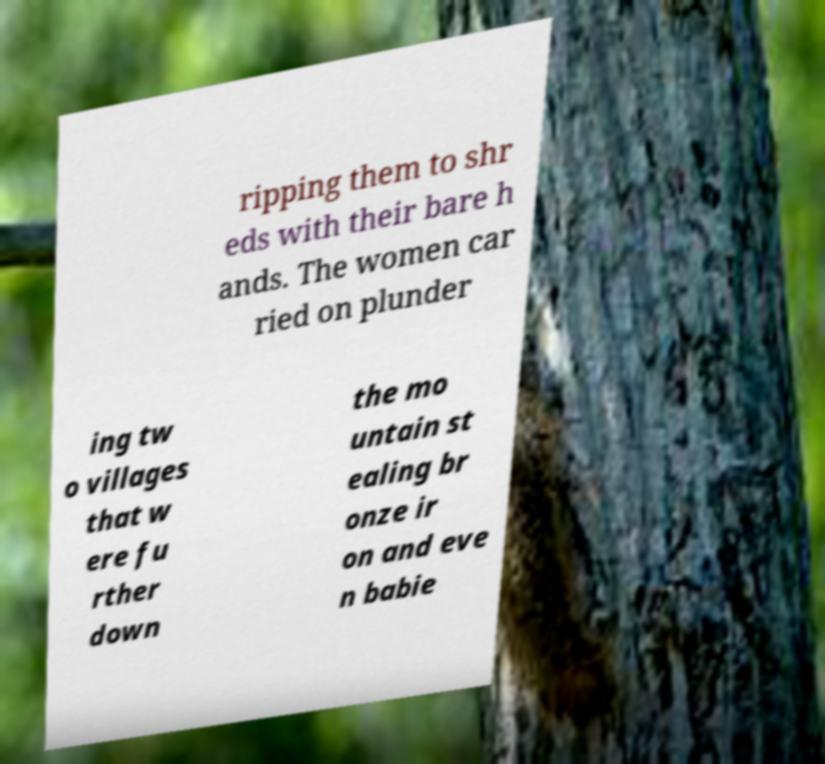Can you read and provide the text displayed in the image?This photo seems to have some interesting text. Can you extract and type it out for me? ripping them to shr eds with their bare h ands. The women car ried on plunder ing tw o villages that w ere fu rther down the mo untain st ealing br onze ir on and eve n babie 